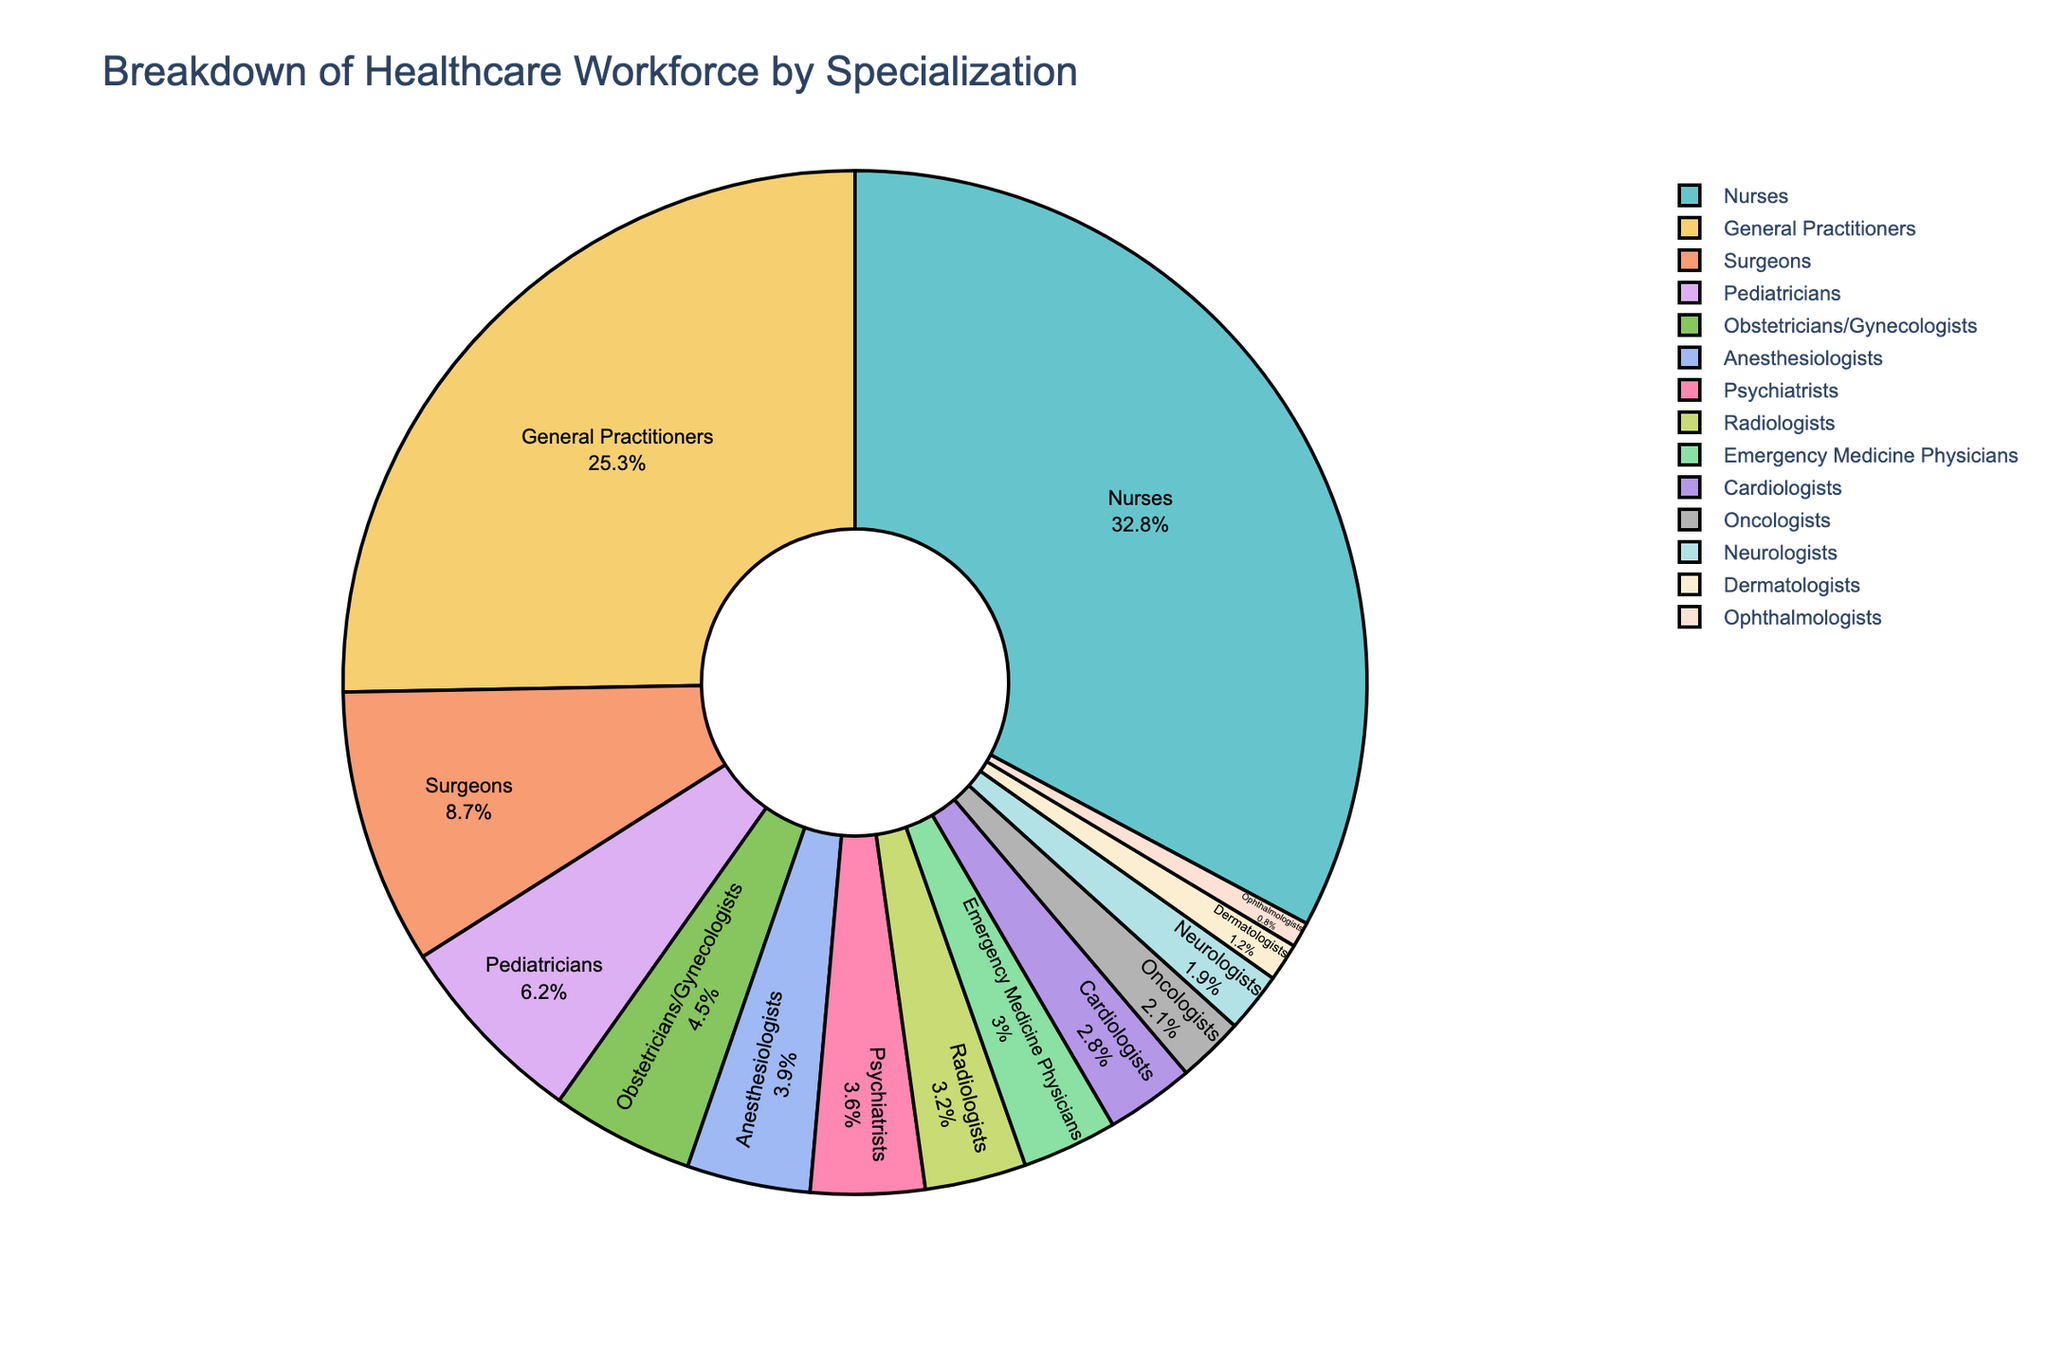Which specialization has the largest proportion of the healthcare workforce? The pie chart shows different specializations with their corresponding percentages. By observing the chart, we can see that Nurses make up 32.8% of the workforce, which is the largest proportion.
Answer: Nurses What's the total percentage for General Practitioners, Surgeons, and Pediatricians combined? By adding the individual percentages: General Practitioners (25.3%) + Surgeons (8.7%) + Pediatricians (6.2%) = 40.2%.
Answer: 40.2% How does the percentage of Psychiatrists compare to Radiologists? Comparing the two percentages: Psychiatrists (3.6%) vs. Radiologists (3.2%). Psychiatrists have a slightly higher percentage than Radiologists.
Answer: Psychiatrists have a higher percentage than Radiologists Which two specializations together form roughly 10% of the workforce? By looking at the percentages, Anesthesiologists (3.9%) and Psychiatrists (3.6%) together make 7.5%, which isn't enough. However, adding Pediatricians (6.2%) and Anesthesiologists (3.9%) gives us 10.1%, which is close to 10%.
Answer: Pediatricians and Anesthesiologists Is the percentage of Ophthalmologists greater than or less than 1%? The chart shows that Ophthalmologists have a percentage of 0.8%.
Answer: Less than 1% What is the difference in percentage between Nurses and General Practitioners? By calculating the difference: Nurses (32.8%) - General Practitioners (25.3%) = 7.5%.
Answer: 7.5% What is the average percentage of Anesthesiologists, Psychiatrists, and Neurologists? Adding the percentages: Anesthesiologists (3.9%) + Psychiatrists (3.6%) + Neurologists (1.9%) = 9.4%, then divide by 3. The average is 9.4% / 3 ≈ 3.13%.
Answer: 3.13% Which specializations have a percentage greater than 5%? By looking at the chart, the specializations with more than 5% are General Practitioners (25.3%), Nurses (32.8%), and Pediatricians (6.2%).
Answer: General Practitioners, Nurses, and Pediatricians How much larger is the slice for Cardiologists compared to Dermatologists? The pie chart shows Cardiologists at 2.8% and Dermatologists at 1.2%. The difference is 2.8% - 1.2% = 1.6%.
Answer: 1.6% 